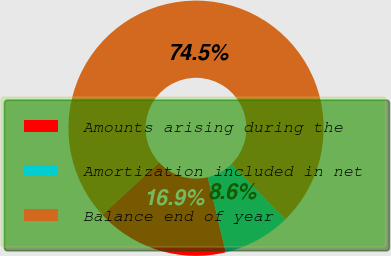Convert chart to OTSL. <chart><loc_0><loc_0><loc_500><loc_500><pie_chart><fcel>Amounts arising during the<fcel>Amortization included in net<fcel>Balance end of year<nl><fcel>16.88%<fcel>8.59%<fcel>74.53%<nl></chart> 